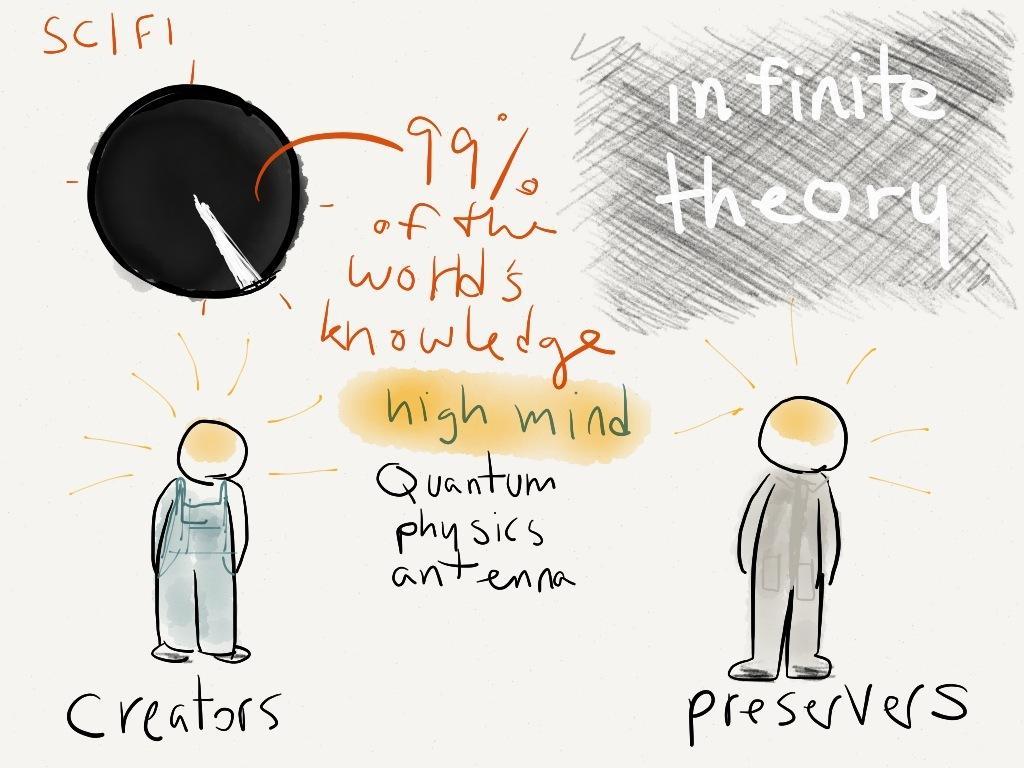Describe this image in one or two sentences. Here this is the picture showing that infinite theory. In the middle there is a note. And on the left side there is a person mentioned it as creators and on the right side one more person is there and mentioned it as preservers. 